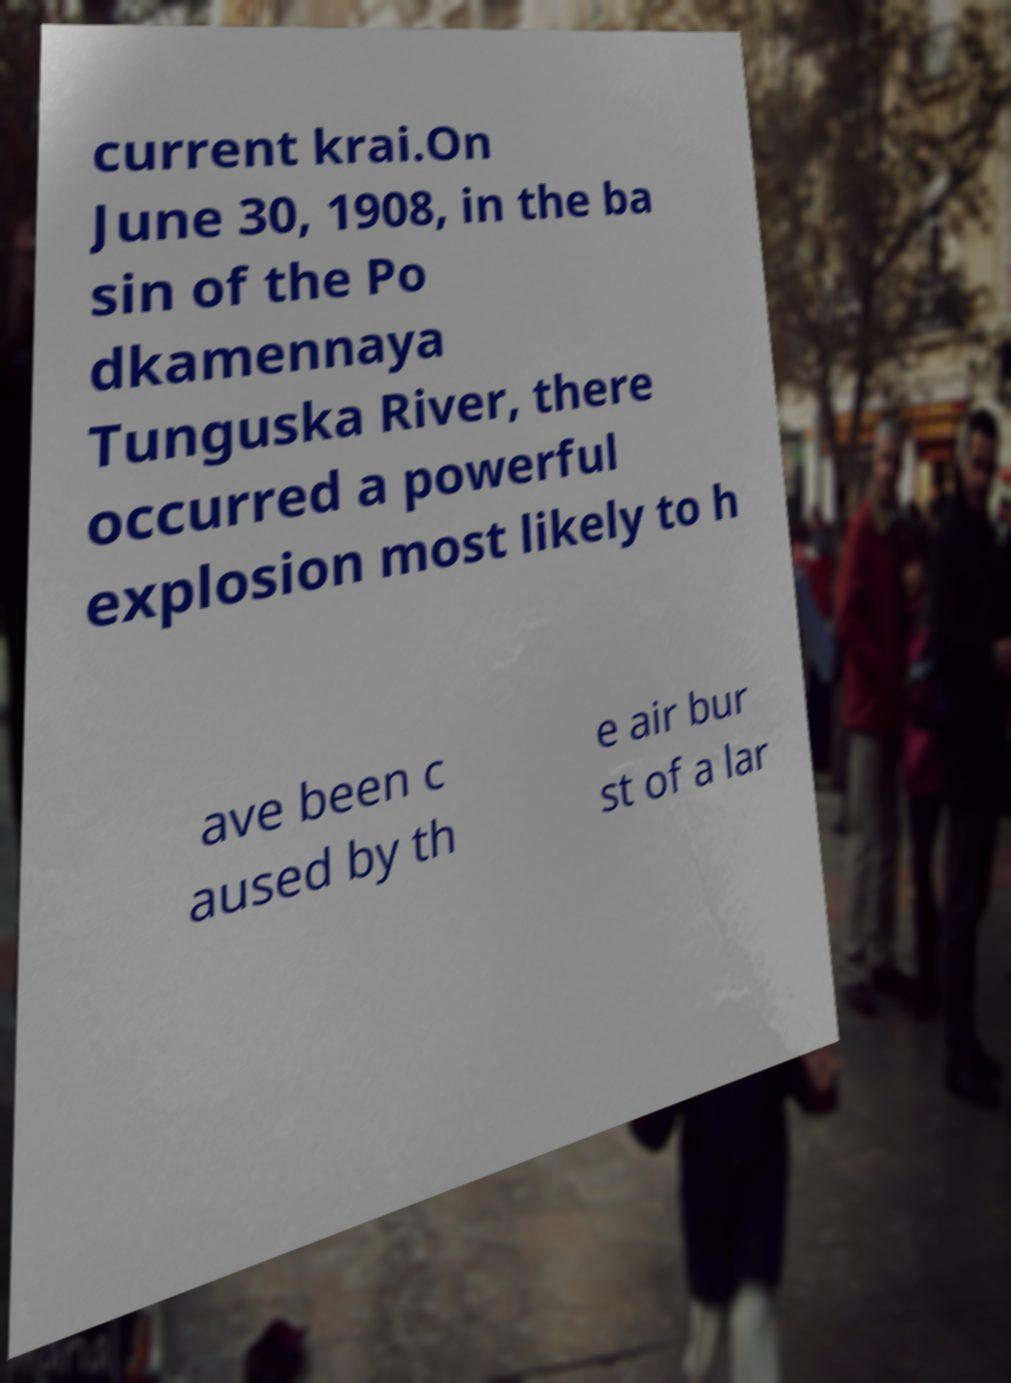Can you read and provide the text displayed in the image?This photo seems to have some interesting text. Can you extract and type it out for me? current krai.On June 30, 1908, in the ba sin of the Po dkamennaya Tunguska River, there occurred a powerful explosion most likely to h ave been c aused by th e air bur st of a lar 